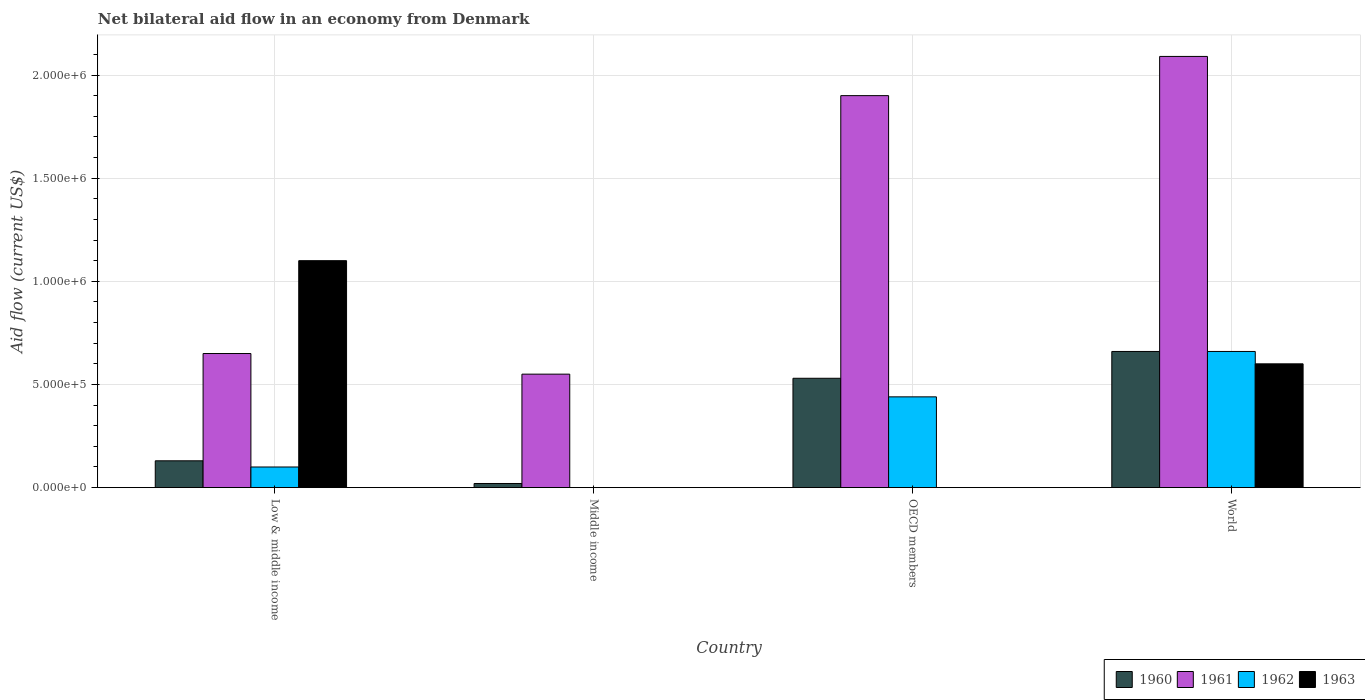Are the number of bars on each tick of the X-axis equal?
Keep it short and to the point. No. What is the label of the 4th group of bars from the left?
Offer a terse response. World. In how many cases, is the number of bars for a given country not equal to the number of legend labels?
Provide a succinct answer. 2. What is the net bilateral aid flow in 1962 in Middle income?
Provide a succinct answer. 0. Across all countries, what is the minimum net bilateral aid flow in 1960?
Keep it short and to the point. 2.00e+04. What is the total net bilateral aid flow in 1963 in the graph?
Your answer should be very brief. 1.70e+06. What is the difference between the net bilateral aid flow in 1961 in Low & middle income and that in World?
Give a very brief answer. -1.44e+06. What is the difference between the net bilateral aid flow in 1960 in Middle income and the net bilateral aid flow in 1962 in World?
Make the answer very short. -6.40e+05. What is the average net bilateral aid flow in 1963 per country?
Offer a very short reply. 4.25e+05. What is the difference between the net bilateral aid flow of/in 1961 and net bilateral aid flow of/in 1962 in OECD members?
Offer a very short reply. 1.46e+06. In how many countries, is the net bilateral aid flow in 1960 greater than 400000 US$?
Provide a succinct answer. 2. What is the ratio of the net bilateral aid flow in 1960 in Middle income to that in World?
Your answer should be compact. 0.03. Is the net bilateral aid flow in 1962 in Low & middle income less than that in OECD members?
Give a very brief answer. Yes. Is the difference between the net bilateral aid flow in 1961 in OECD members and World greater than the difference between the net bilateral aid flow in 1962 in OECD members and World?
Provide a succinct answer. Yes. What is the difference between the highest and the lowest net bilateral aid flow in 1960?
Provide a short and direct response. 6.40e+05. In how many countries, is the net bilateral aid flow in 1961 greater than the average net bilateral aid flow in 1961 taken over all countries?
Offer a very short reply. 2. Is it the case that in every country, the sum of the net bilateral aid flow in 1962 and net bilateral aid flow in 1963 is greater than the net bilateral aid flow in 1961?
Your answer should be compact. No. Does the graph contain grids?
Your response must be concise. Yes. Where does the legend appear in the graph?
Keep it short and to the point. Bottom right. What is the title of the graph?
Give a very brief answer. Net bilateral aid flow in an economy from Denmark. Does "1988" appear as one of the legend labels in the graph?
Make the answer very short. No. What is the Aid flow (current US$) in 1960 in Low & middle income?
Ensure brevity in your answer.  1.30e+05. What is the Aid flow (current US$) of 1961 in Low & middle income?
Ensure brevity in your answer.  6.50e+05. What is the Aid flow (current US$) of 1963 in Low & middle income?
Your answer should be compact. 1.10e+06. What is the Aid flow (current US$) of 1960 in Middle income?
Give a very brief answer. 2.00e+04. What is the Aid flow (current US$) of 1961 in Middle income?
Make the answer very short. 5.50e+05. What is the Aid flow (current US$) of 1962 in Middle income?
Your answer should be compact. 0. What is the Aid flow (current US$) in 1963 in Middle income?
Provide a short and direct response. 0. What is the Aid flow (current US$) of 1960 in OECD members?
Keep it short and to the point. 5.30e+05. What is the Aid flow (current US$) in 1961 in OECD members?
Make the answer very short. 1.90e+06. What is the Aid flow (current US$) of 1962 in OECD members?
Offer a very short reply. 4.40e+05. What is the Aid flow (current US$) of 1960 in World?
Offer a terse response. 6.60e+05. What is the Aid flow (current US$) in 1961 in World?
Provide a short and direct response. 2.09e+06. What is the Aid flow (current US$) in 1962 in World?
Give a very brief answer. 6.60e+05. What is the Aid flow (current US$) in 1963 in World?
Give a very brief answer. 6.00e+05. Across all countries, what is the maximum Aid flow (current US$) in 1961?
Provide a succinct answer. 2.09e+06. Across all countries, what is the maximum Aid flow (current US$) in 1963?
Your answer should be very brief. 1.10e+06. Across all countries, what is the minimum Aid flow (current US$) in 1961?
Keep it short and to the point. 5.50e+05. Across all countries, what is the minimum Aid flow (current US$) in 1962?
Give a very brief answer. 0. Across all countries, what is the minimum Aid flow (current US$) of 1963?
Your answer should be very brief. 0. What is the total Aid flow (current US$) of 1960 in the graph?
Your answer should be compact. 1.34e+06. What is the total Aid flow (current US$) in 1961 in the graph?
Your response must be concise. 5.19e+06. What is the total Aid flow (current US$) in 1962 in the graph?
Ensure brevity in your answer.  1.20e+06. What is the total Aid flow (current US$) in 1963 in the graph?
Your answer should be compact. 1.70e+06. What is the difference between the Aid flow (current US$) of 1960 in Low & middle income and that in Middle income?
Make the answer very short. 1.10e+05. What is the difference between the Aid flow (current US$) of 1960 in Low & middle income and that in OECD members?
Keep it short and to the point. -4.00e+05. What is the difference between the Aid flow (current US$) of 1961 in Low & middle income and that in OECD members?
Offer a very short reply. -1.25e+06. What is the difference between the Aid flow (current US$) in 1960 in Low & middle income and that in World?
Keep it short and to the point. -5.30e+05. What is the difference between the Aid flow (current US$) in 1961 in Low & middle income and that in World?
Provide a short and direct response. -1.44e+06. What is the difference between the Aid flow (current US$) in 1962 in Low & middle income and that in World?
Ensure brevity in your answer.  -5.60e+05. What is the difference between the Aid flow (current US$) of 1963 in Low & middle income and that in World?
Your answer should be very brief. 5.00e+05. What is the difference between the Aid flow (current US$) of 1960 in Middle income and that in OECD members?
Make the answer very short. -5.10e+05. What is the difference between the Aid flow (current US$) of 1961 in Middle income and that in OECD members?
Provide a succinct answer. -1.35e+06. What is the difference between the Aid flow (current US$) in 1960 in Middle income and that in World?
Ensure brevity in your answer.  -6.40e+05. What is the difference between the Aid flow (current US$) of 1961 in Middle income and that in World?
Your response must be concise. -1.54e+06. What is the difference between the Aid flow (current US$) of 1960 in OECD members and that in World?
Your answer should be compact. -1.30e+05. What is the difference between the Aid flow (current US$) of 1961 in OECD members and that in World?
Offer a very short reply. -1.90e+05. What is the difference between the Aid flow (current US$) in 1962 in OECD members and that in World?
Give a very brief answer. -2.20e+05. What is the difference between the Aid flow (current US$) in 1960 in Low & middle income and the Aid flow (current US$) in 1961 in Middle income?
Make the answer very short. -4.20e+05. What is the difference between the Aid flow (current US$) in 1960 in Low & middle income and the Aid flow (current US$) in 1961 in OECD members?
Ensure brevity in your answer.  -1.77e+06. What is the difference between the Aid flow (current US$) in 1960 in Low & middle income and the Aid flow (current US$) in 1962 in OECD members?
Provide a succinct answer. -3.10e+05. What is the difference between the Aid flow (current US$) of 1960 in Low & middle income and the Aid flow (current US$) of 1961 in World?
Offer a terse response. -1.96e+06. What is the difference between the Aid flow (current US$) of 1960 in Low & middle income and the Aid flow (current US$) of 1962 in World?
Make the answer very short. -5.30e+05. What is the difference between the Aid flow (current US$) of 1960 in Low & middle income and the Aid flow (current US$) of 1963 in World?
Your answer should be compact. -4.70e+05. What is the difference between the Aid flow (current US$) in 1962 in Low & middle income and the Aid flow (current US$) in 1963 in World?
Give a very brief answer. -5.00e+05. What is the difference between the Aid flow (current US$) in 1960 in Middle income and the Aid flow (current US$) in 1961 in OECD members?
Give a very brief answer. -1.88e+06. What is the difference between the Aid flow (current US$) in 1960 in Middle income and the Aid flow (current US$) in 1962 in OECD members?
Your answer should be compact. -4.20e+05. What is the difference between the Aid flow (current US$) of 1960 in Middle income and the Aid flow (current US$) of 1961 in World?
Keep it short and to the point. -2.07e+06. What is the difference between the Aid flow (current US$) of 1960 in Middle income and the Aid flow (current US$) of 1962 in World?
Give a very brief answer. -6.40e+05. What is the difference between the Aid flow (current US$) of 1960 in Middle income and the Aid flow (current US$) of 1963 in World?
Your response must be concise. -5.80e+05. What is the difference between the Aid flow (current US$) in 1961 in Middle income and the Aid flow (current US$) in 1963 in World?
Your answer should be very brief. -5.00e+04. What is the difference between the Aid flow (current US$) in 1960 in OECD members and the Aid flow (current US$) in 1961 in World?
Provide a short and direct response. -1.56e+06. What is the difference between the Aid flow (current US$) of 1960 in OECD members and the Aid flow (current US$) of 1962 in World?
Make the answer very short. -1.30e+05. What is the difference between the Aid flow (current US$) in 1961 in OECD members and the Aid flow (current US$) in 1962 in World?
Make the answer very short. 1.24e+06. What is the difference between the Aid flow (current US$) of 1961 in OECD members and the Aid flow (current US$) of 1963 in World?
Give a very brief answer. 1.30e+06. What is the average Aid flow (current US$) in 1960 per country?
Your response must be concise. 3.35e+05. What is the average Aid flow (current US$) in 1961 per country?
Your answer should be very brief. 1.30e+06. What is the average Aid flow (current US$) in 1963 per country?
Your answer should be very brief. 4.25e+05. What is the difference between the Aid flow (current US$) of 1960 and Aid flow (current US$) of 1961 in Low & middle income?
Make the answer very short. -5.20e+05. What is the difference between the Aid flow (current US$) of 1960 and Aid flow (current US$) of 1963 in Low & middle income?
Provide a succinct answer. -9.70e+05. What is the difference between the Aid flow (current US$) in 1961 and Aid flow (current US$) in 1963 in Low & middle income?
Your response must be concise. -4.50e+05. What is the difference between the Aid flow (current US$) of 1962 and Aid flow (current US$) of 1963 in Low & middle income?
Keep it short and to the point. -1.00e+06. What is the difference between the Aid flow (current US$) in 1960 and Aid flow (current US$) in 1961 in Middle income?
Provide a short and direct response. -5.30e+05. What is the difference between the Aid flow (current US$) in 1960 and Aid flow (current US$) in 1961 in OECD members?
Your response must be concise. -1.37e+06. What is the difference between the Aid flow (current US$) of 1960 and Aid flow (current US$) of 1962 in OECD members?
Your answer should be very brief. 9.00e+04. What is the difference between the Aid flow (current US$) of 1961 and Aid flow (current US$) of 1962 in OECD members?
Your answer should be compact. 1.46e+06. What is the difference between the Aid flow (current US$) in 1960 and Aid flow (current US$) in 1961 in World?
Make the answer very short. -1.43e+06. What is the difference between the Aid flow (current US$) of 1960 and Aid flow (current US$) of 1963 in World?
Offer a terse response. 6.00e+04. What is the difference between the Aid flow (current US$) of 1961 and Aid flow (current US$) of 1962 in World?
Provide a succinct answer. 1.43e+06. What is the difference between the Aid flow (current US$) of 1961 and Aid flow (current US$) of 1963 in World?
Give a very brief answer. 1.49e+06. What is the difference between the Aid flow (current US$) of 1962 and Aid flow (current US$) of 1963 in World?
Provide a succinct answer. 6.00e+04. What is the ratio of the Aid flow (current US$) in 1961 in Low & middle income to that in Middle income?
Your answer should be compact. 1.18. What is the ratio of the Aid flow (current US$) in 1960 in Low & middle income to that in OECD members?
Offer a very short reply. 0.25. What is the ratio of the Aid flow (current US$) in 1961 in Low & middle income to that in OECD members?
Ensure brevity in your answer.  0.34. What is the ratio of the Aid flow (current US$) of 1962 in Low & middle income to that in OECD members?
Provide a short and direct response. 0.23. What is the ratio of the Aid flow (current US$) of 1960 in Low & middle income to that in World?
Offer a terse response. 0.2. What is the ratio of the Aid flow (current US$) in 1961 in Low & middle income to that in World?
Your response must be concise. 0.31. What is the ratio of the Aid flow (current US$) in 1962 in Low & middle income to that in World?
Provide a succinct answer. 0.15. What is the ratio of the Aid flow (current US$) in 1963 in Low & middle income to that in World?
Your answer should be compact. 1.83. What is the ratio of the Aid flow (current US$) in 1960 in Middle income to that in OECD members?
Ensure brevity in your answer.  0.04. What is the ratio of the Aid flow (current US$) in 1961 in Middle income to that in OECD members?
Your response must be concise. 0.29. What is the ratio of the Aid flow (current US$) in 1960 in Middle income to that in World?
Provide a short and direct response. 0.03. What is the ratio of the Aid flow (current US$) of 1961 in Middle income to that in World?
Make the answer very short. 0.26. What is the ratio of the Aid flow (current US$) of 1960 in OECD members to that in World?
Provide a succinct answer. 0.8. What is the ratio of the Aid flow (current US$) in 1962 in OECD members to that in World?
Offer a very short reply. 0.67. What is the difference between the highest and the lowest Aid flow (current US$) in 1960?
Your answer should be compact. 6.40e+05. What is the difference between the highest and the lowest Aid flow (current US$) in 1961?
Your response must be concise. 1.54e+06. What is the difference between the highest and the lowest Aid flow (current US$) of 1963?
Offer a terse response. 1.10e+06. 